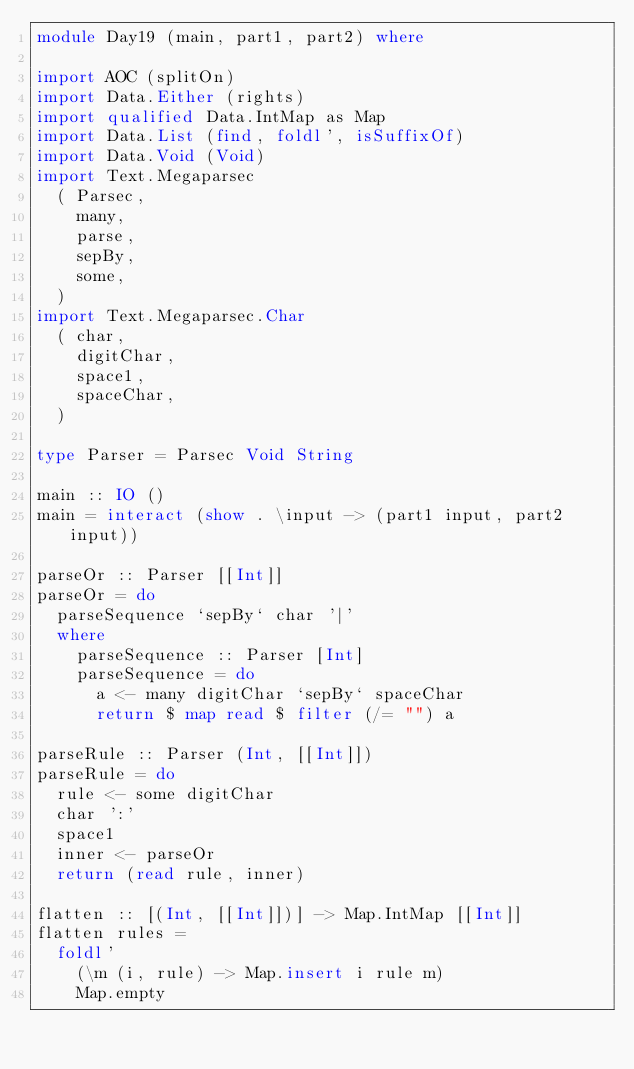Convert code to text. <code><loc_0><loc_0><loc_500><loc_500><_Haskell_>module Day19 (main, part1, part2) where

import AOC (splitOn)
import Data.Either (rights)
import qualified Data.IntMap as Map
import Data.List (find, foldl', isSuffixOf)
import Data.Void (Void)
import Text.Megaparsec
  ( Parsec,
    many,
    parse,
    sepBy,
    some,
  )
import Text.Megaparsec.Char
  ( char,
    digitChar,
    space1,
    spaceChar,
  )

type Parser = Parsec Void String

main :: IO ()
main = interact (show . \input -> (part1 input, part2 input))

parseOr :: Parser [[Int]]
parseOr = do
  parseSequence `sepBy` char '|'
  where
    parseSequence :: Parser [Int]
    parseSequence = do
      a <- many digitChar `sepBy` spaceChar
      return $ map read $ filter (/= "") a

parseRule :: Parser (Int, [[Int]])
parseRule = do
  rule <- some digitChar
  char ':'
  space1
  inner <- parseOr
  return (read rule, inner)

flatten :: [(Int, [[Int]])] -> Map.IntMap [[Int]]
flatten rules =
  foldl'
    (\m (i, rule) -> Map.insert i rule m)
    Map.empty</code> 